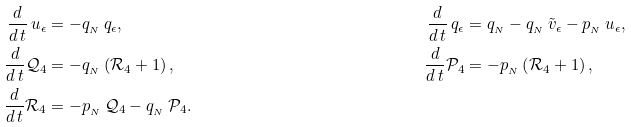<formula> <loc_0><loc_0><loc_500><loc_500>\frac { d } { d \, t } \, u _ { \epsilon } & = - q _ { _ { N } } \, q _ { \epsilon } , & \frac { d } { d \, t } \, q _ { \epsilon } & = q _ { _ { N } } - q _ { _ { N } } \, \tilde { v } _ { \epsilon } - p _ { _ { N } } \, u _ { \epsilon } , \\ \frac { d } { d \, t } \mathcal { Q } _ { 4 } & = - q _ { _ { N } } \left ( \mathcal { R } _ { 4 } + 1 \right ) , & \frac { d } { d \, t } \mathcal { P } _ { 4 } & = - p _ { _ { N } } \left ( \mathcal { R } _ { 4 } + 1 \right ) , \\ \frac { d } { d \, t } \mathcal { R } _ { 4 } & = - p _ { _ { N } } \, \mathcal { Q } _ { 4 } - q _ { _ { N } } \, \mathcal { P } _ { 4 } . &</formula> 